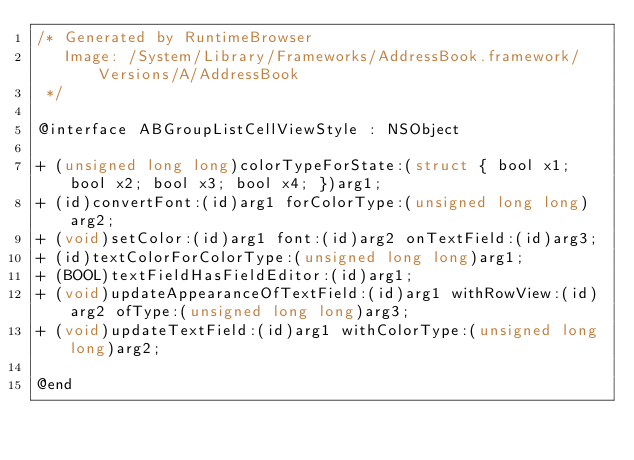<code> <loc_0><loc_0><loc_500><loc_500><_C_>/* Generated by RuntimeBrowser
   Image: /System/Library/Frameworks/AddressBook.framework/Versions/A/AddressBook
 */

@interface ABGroupListCellViewStyle : NSObject

+ (unsigned long long)colorTypeForState:(struct { bool x1; bool x2; bool x3; bool x4; })arg1;
+ (id)convertFont:(id)arg1 forColorType:(unsigned long long)arg2;
+ (void)setColor:(id)arg1 font:(id)arg2 onTextField:(id)arg3;
+ (id)textColorForColorType:(unsigned long long)arg1;
+ (BOOL)textFieldHasFieldEditor:(id)arg1;
+ (void)updateAppearanceOfTextField:(id)arg1 withRowView:(id)arg2 ofType:(unsigned long long)arg3;
+ (void)updateTextField:(id)arg1 withColorType:(unsigned long long)arg2;

@end
</code> 